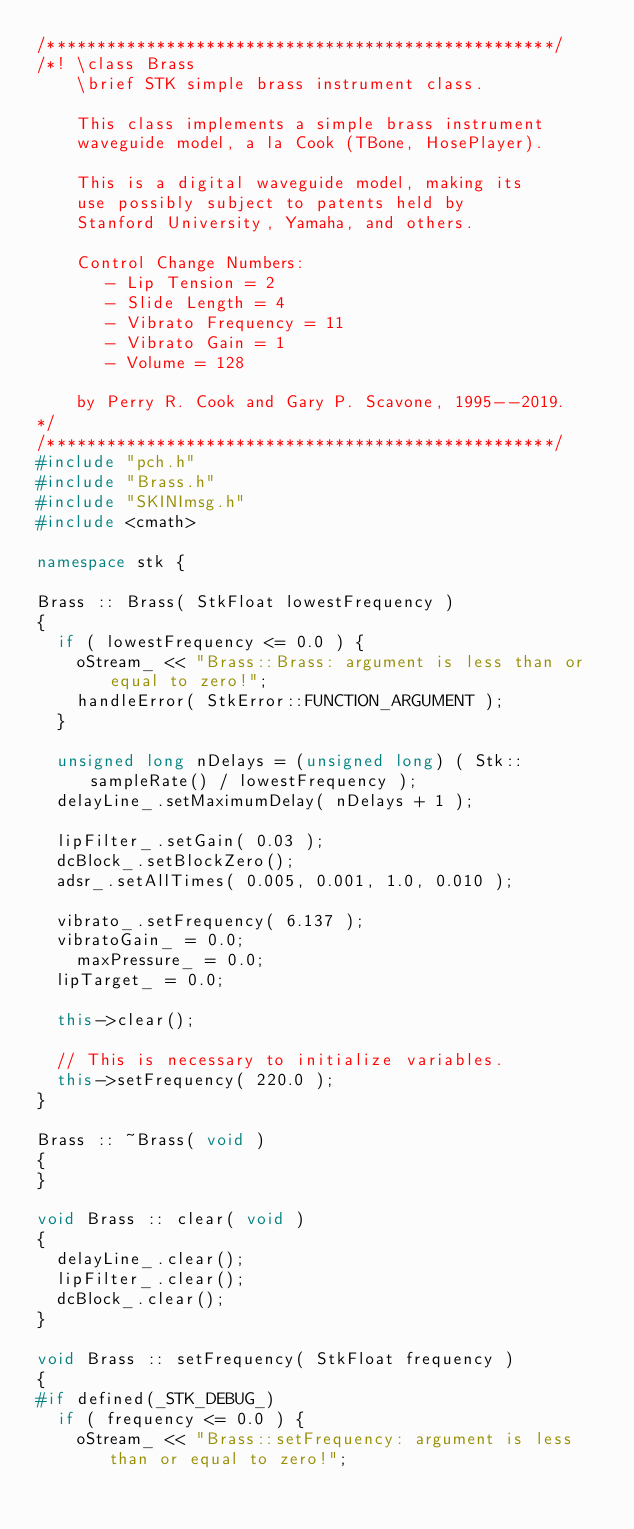Convert code to text. <code><loc_0><loc_0><loc_500><loc_500><_C++_>/***************************************************/
/*! \class Brass
    \brief STK simple brass instrument class.

    This class implements a simple brass instrument
    waveguide model, a la Cook (TBone, HosePlayer).

    This is a digital waveguide model, making its
    use possibly subject to patents held by
    Stanford University, Yamaha, and others.

    Control Change Numbers: 
       - Lip Tension = 2
       - Slide Length = 4
       - Vibrato Frequency = 11
       - Vibrato Gain = 1
       - Volume = 128

    by Perry R. Cook and Gary P. Scavone, 1995--2019.
*/
/***************************************************/
#include "pch.h" 
#include "Brass.h"
#include "SKINImsg.h"
#include <cmath>

namespace stk {

Brass :: Brass( StkFloat lowestFrequency )
{
  if ( lowestFrequency <= 0.0 ) {
    oStream_ << "Brass::Brass: argument is less than or equal to zero!";
    handleError( StkError::FUNCTION_ARGUMENT );
  }

  unsigned long nDelays = (unsigned long) ( Stk::sampleRate() / lowestFrequency );
  delayLine_.setMaximumDelay( nDelays + 1 );

  lipFilter_.setGain( 0.03 );
  dcBlock_.setBlockZero();
  adsr_.setAllTimes( 0.005, 0.001, 1.0, 0.010 );

  vibrato_.setFrequency( 6.137 );
  vibratoGain_ = 0.0;
	maxPressure_ = 0.0;
  lipTarget_ = 0.0;

  this->clear();

  // This is necessary to initialize variables.
  this->setFrequency( 220.0 );
}

Brass :: ~Brass( void )
{
}

void Brass :: clear( void )
{
  delayLine_.clear();
  lipFilter_.clear();
  dcBlock_.clear();
}

void Brass :: setFrequency( StkFloat frequency )
{
#if defined(_STK_DEBUG_)
  if ( frequency <= 0.0 ) {
    oStream_ << "Brass::setFrequency: argument is less than or equal to zero!";</code> 